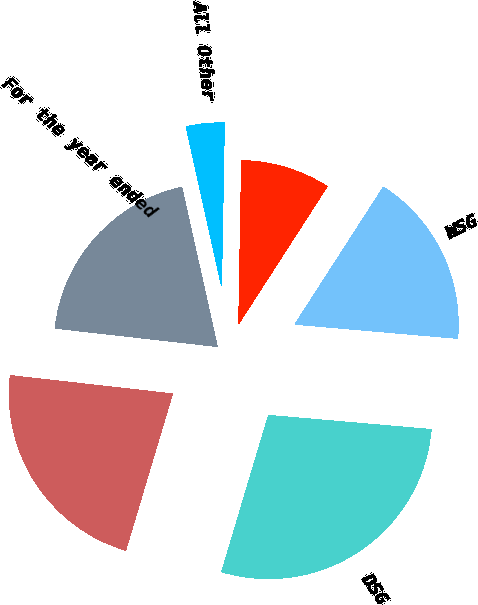Convert chart. <chart><loc_0><loc_0><loc_500><loc_500><pie_chart><fcel>For the year ended<fcel>NSG<fcel>DSG<fcel>WSG<fcel>ESG<fcel>All Other<nl><fcel>19.72%<fcel>22.16%<fcel>28.24%<fcel>17.27%<fcel>8.83%<fcel>3.77%<nl></chart> 